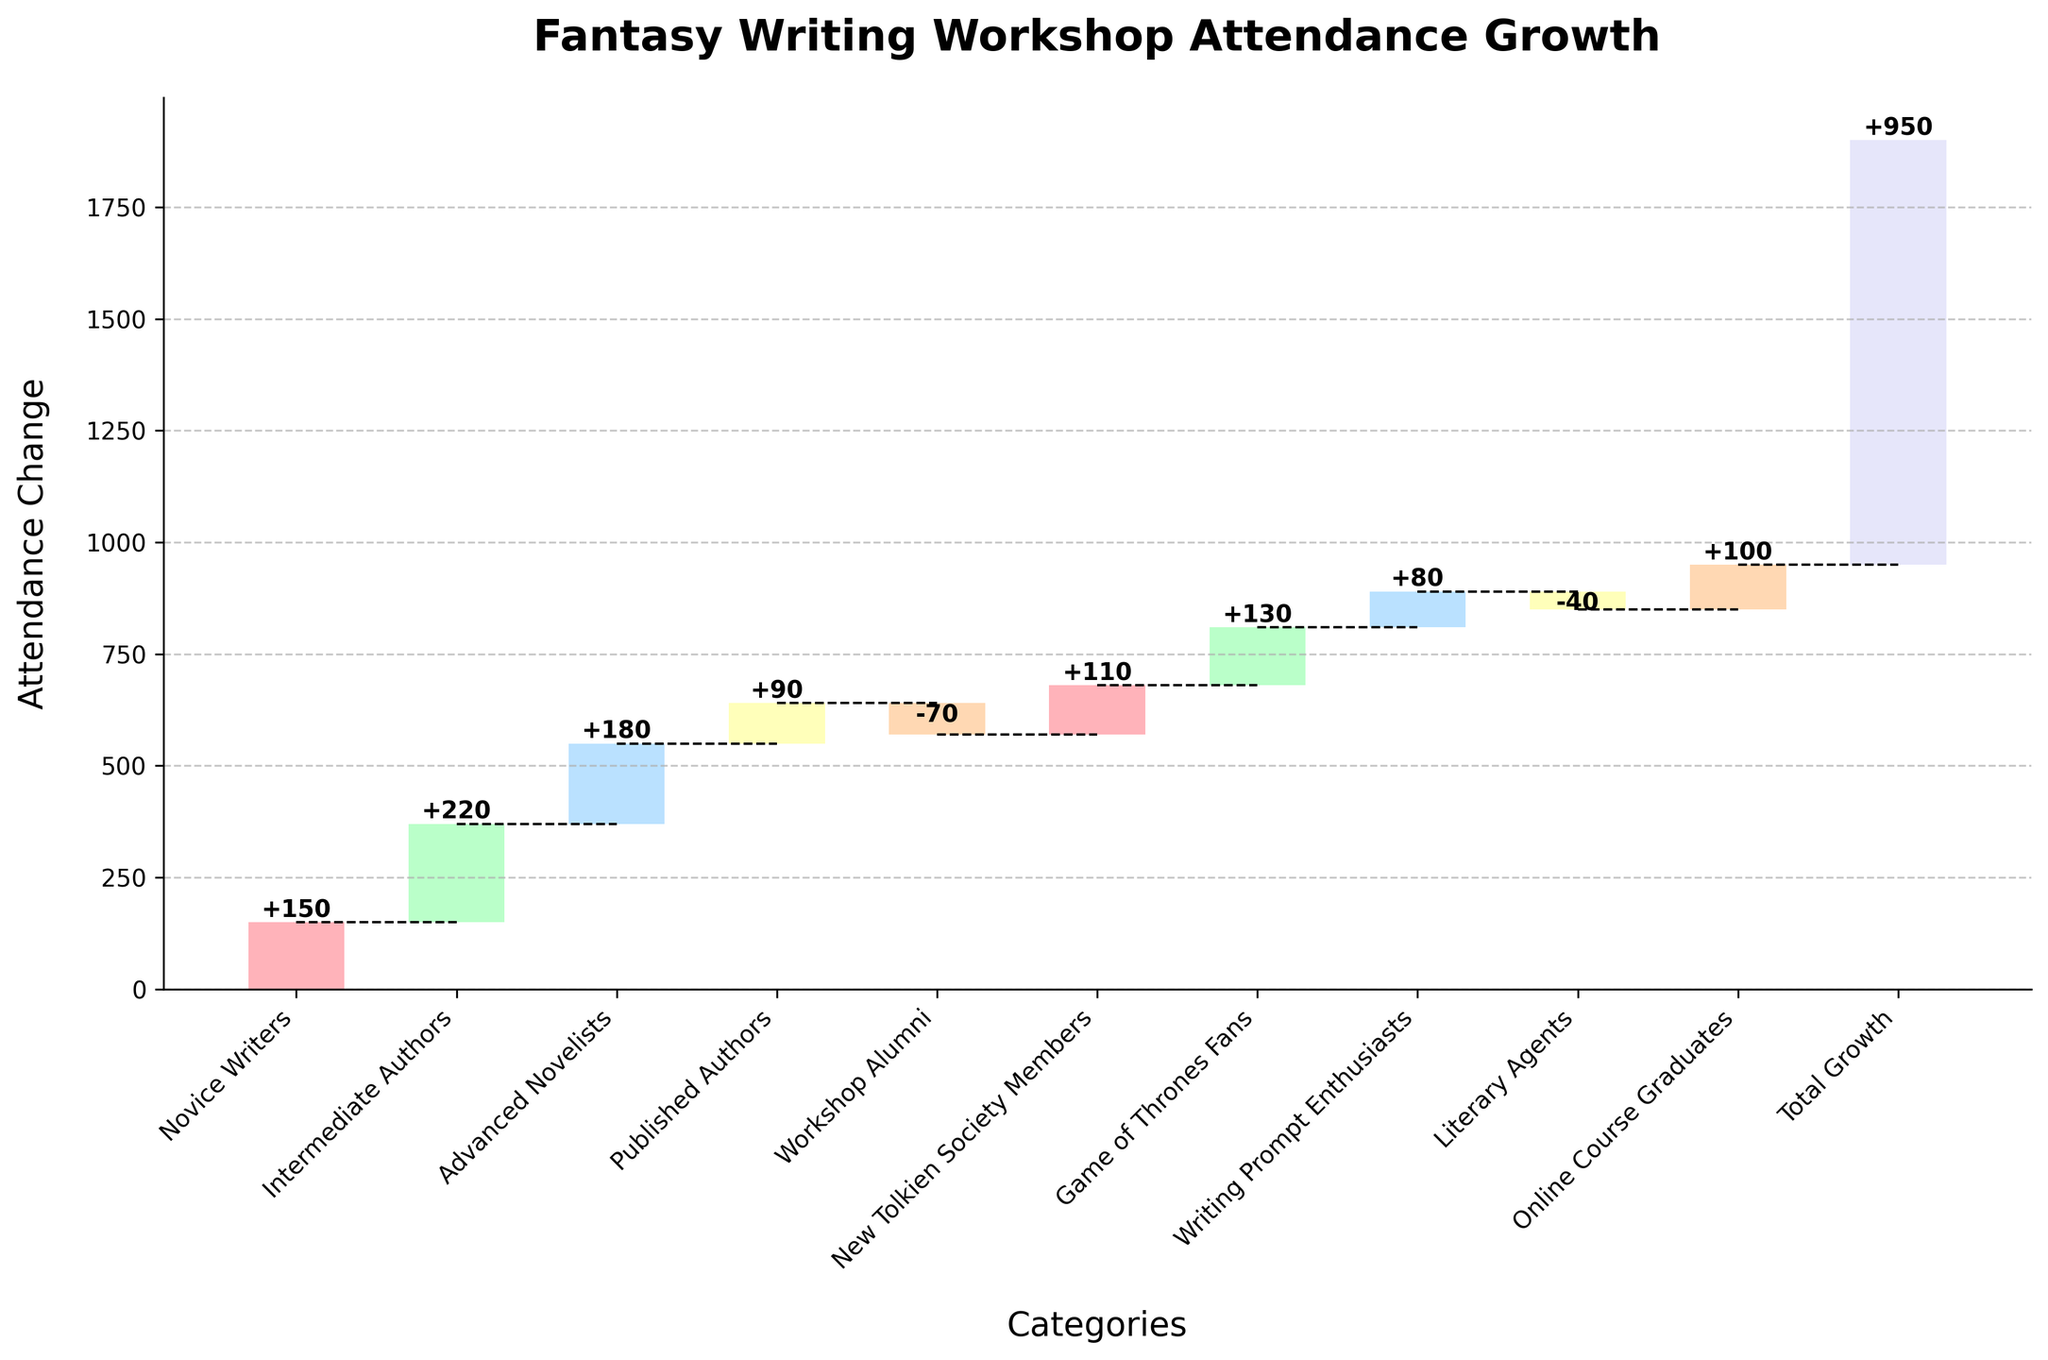What is the title of the chart? The title of the chart is clearly displayed at the top, indicating the subject of the visualization.
Answer: Fantasy Writing Workshop Attendance Growth Which experience level category has the highest attendance change? By visually inspecting the height of the bars, the category labeled "Intermediate Authors" has the tallest bar.
Answer: Intermediate Authors What is the overall attendance growth shown in the chart? The total attendance growth is shown as the last category labeled "Total Growth" on the x-axis.
Answer: 950 What effect did "Workshop Alumni" have on attendance? We see a negative effect for "Workshop Alumni" as indicated by a drop downwards on the chart with a negative value displayed.
Answer: -70 Calculate the cumulative attendance change after including "Advanced Novelists". Add the values of "Novice Writers", "Intermediate Authors", and "Advanced Novelists": 150 + 220 + 180 = 550.
Answer: 550 What is the attendance change contributed by "Literary Agents" and "Online Course Graduates" combined? Sum the values associated with "Literary Agents" and "Online Course Graduates": -40 + 100 = 60.
Answer: 60 Which categories show a negative impact on the attendance growth? By identifying the bars pointing downwards, the categories "Workshop Alumni" and "Literary Agents" represent negative impacts.
Answer: Workshop Alumni, Literary Agents Compare the attendance change between "Game of Thrones Fans" and "New Tolkien Society Members". Which one contributed more to the growth? By comparing the heights of the two bars, "Game of Thrones Fans" has a higher bar than "New Tolkien Society Members".
Answer: Game of Thrones Fans How many categories contributed positively to the attendance growth? Count all the bars that extend upwards, indicating a positive value: "Novice Writers", "Intermediate Authors", "Advanced Novelists", "Published Authors", "New Tolkien Society Members", "Game of Thrones Fans", "Writing Prompt Enthusiasts", "Online Course Graduates". There are 8 categories.
Answer: 8 What's the difference in attendance change between "Novice Writers" and "Published Authors"? Subtract the value of "Published Authors" from "Novice Writers": 150 - 90 = 60.
Answer: 60 